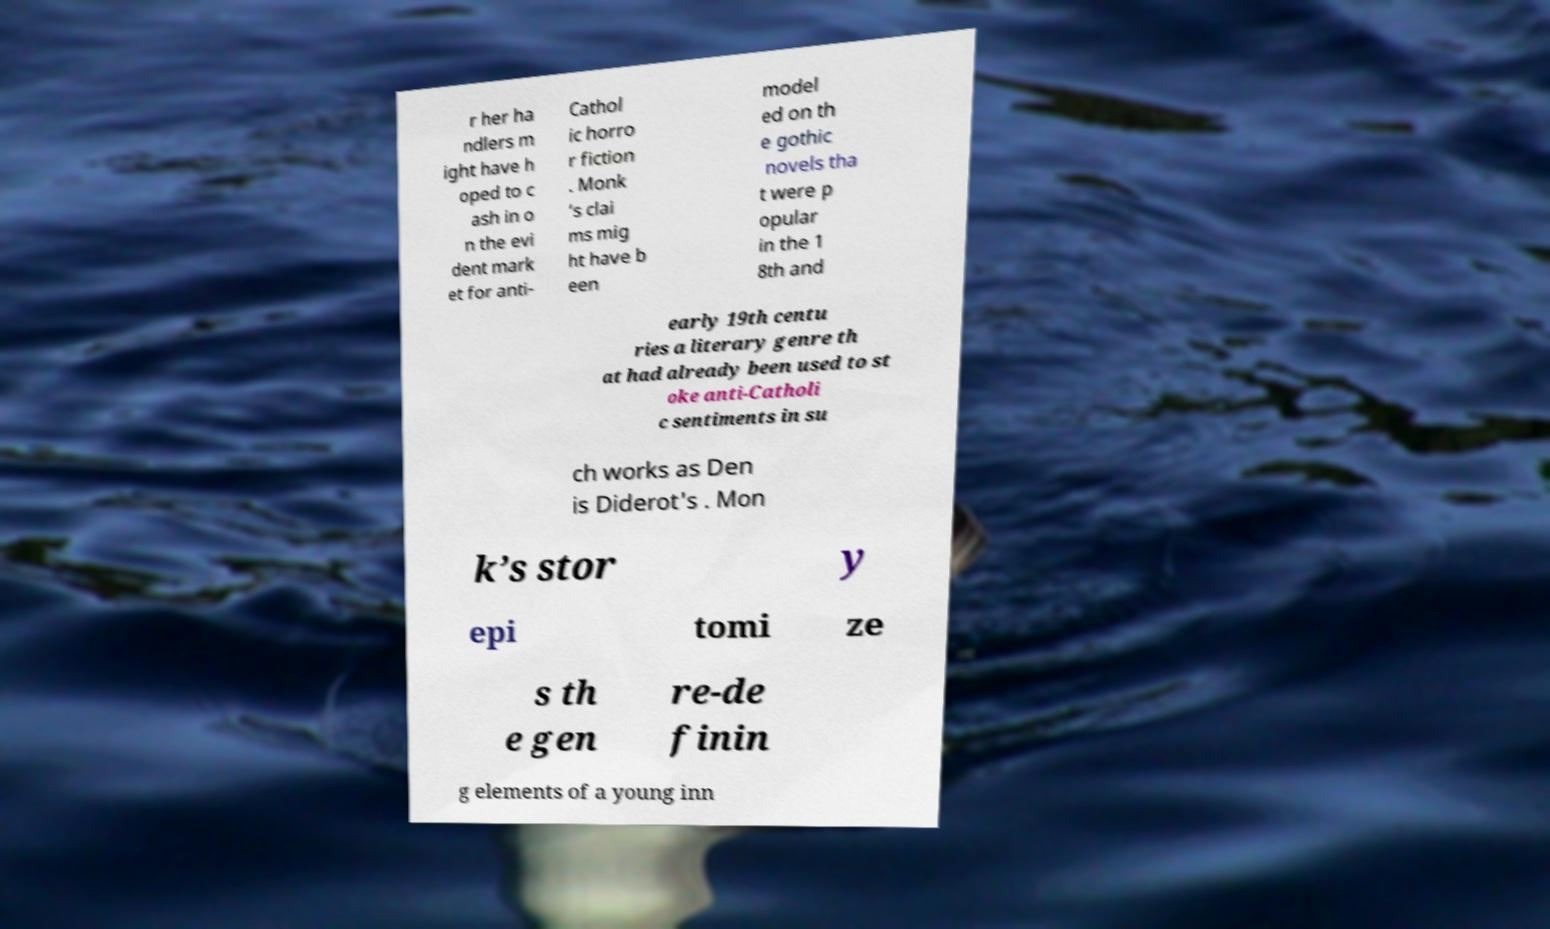What messages or text are displayed in this image? I need them in a readable, typed format. r her ha ndlers m ight have h oped to c ash in o n the evi dent mark et for anti- Cathol ic horro r fiction . Monk ’s clai ms mig ht have b een model ed on th e gothic novels tha t were p opular in the 1 8th and early 19th centu ries a literary genre th at had already been used to st oke anti-Catholi c sentiments in su ch works as Den is Diderot's . Mon k’s stor y epi tomi ze s th e gen re-de finin g elements of a young inn 